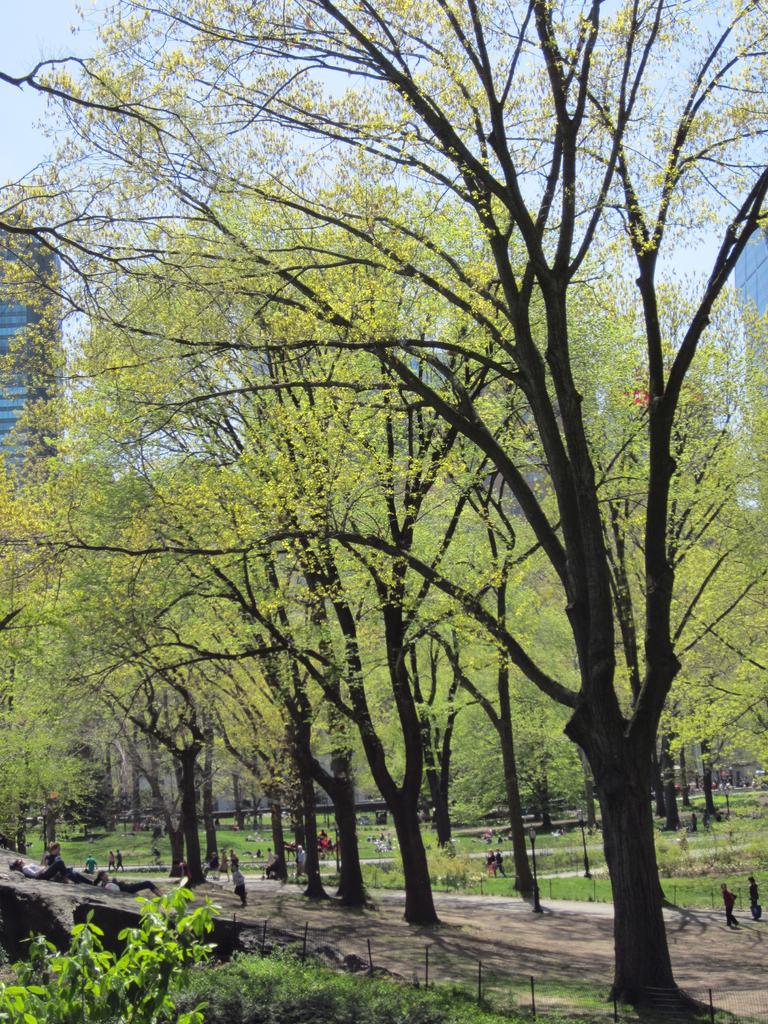What type of vegetation can be seen in the image? There are trees, plants, and grass in the image. Can you describe the people in the image? There are people in the image, but their specific actions or appearances are not mentioned in the facts. What type of barrier is present in the image? There is a fence in the image. What other objects can be found on the ground in the image? There are other objects on the ground in the image, but their specific nature is not mentioned in the facts. What can be seen in the background of the image? There are buildings and the sky visible in the background of the image. What time of day is it in the image, according to the hour? The facts provided do not mention the time of day or any specific hour, so it cannot be determined from the image. How many brothers are present in the image? There is no mention of brothers or any familial relationships in the facts provided, so it cannot be determined from the image. 